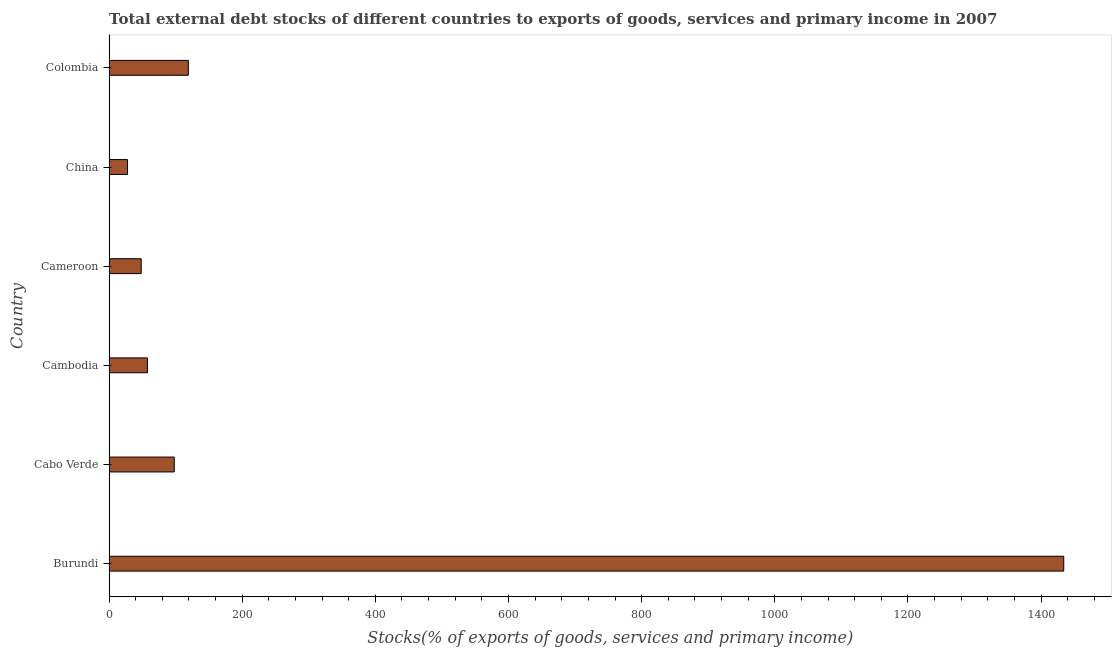Does the graph contain any zero values?
Provide a short and direct response. No. Does the graph contain grids?
Offer a terse response. No. What is the title of the graph?
Keep it short and to the point. Total external debt stocks of different countries to exports of goods, services and primary income in 2007. What is the label or title of the X-axis?
Offer a very short reply. Stocks(% of exports of goods, services and primary income). What is the external debt stocks in Cameroon?
Provide a succinct answer. 48.27. Across all countries, what is the maximum external debt stocks?
Your answer should be very brief. 1434.09. Across all countries, what is the minimum external debt stocks?
Offer a terse response. 27.76. In which country was the external debt stocks maximum?
Provide a short and direct response. Burundi. What is the sum of the external debt stocks?
Provide a succinct answer. 1784.75. What is the difference between the external debt stocks in Cabo Verde and Cambodia?
Your response must be concise. 40.35. What is the average external debt stocks per country?
Your answer should be compact. 297.46. What is the median external debt stocks?
Make the answer very short. 77.77. What is the ratio of the external debt stocks in Burundi to that in Cabo Verde?
Offer a very short reply. 14.64. Is the difference between the external debt stocks in Burundi and Cabo Verde greater than the difference between any two countries?
Offer a terse response. No. What is the difference between the highest and the second highest external debt stocks?
Your response must be concise. 1315.01. Is the sum of the external debt stocks in Cameroon and Colombia greater than the maximum external debt stocks across all countries?
Offer a terse response. No. What is the difference between the highest and the lowest external debt stocks?
Your answer should be very brief. 1406.33. In how many countries, is the external debt stocks greater than the average external debt stocks taken over all countries?
Your answer should be compact. 1. Are all the bars in the graph horizontal?
Your answer should be compact. Yes. How many countries are there in the graph?
Ensure brevity in your answer.  6. What is the Stocks(% of exports of goods, services and primary income) in Burundi?
Offer a very short reply. 1434.09. What is the Stocks(% of exports of goods, services and primary income) in Cabo Verde?
Offer a very short reply. 97.95. What is the Stocks(% of exports of goods, services and primary income) of Cambodia?
Your answer should be very brief. 57.59. What is the Stocks(% of exports of goods, services and primary income) of Cameroon?
Give a very brief answer. 48.27. What is the Stocks(% of exports of goods, services and primary income) in China?
Provide a succinct answer. 27.76. What is the Stocks(% of exports of goods, services and primary income) of Colombia?
Give a very brief answer. 119.08. What is the difference between the Stocks(% of exports of goods, services and primary income) in Burundi and Cabo Verde?
Your answer should be very brief. 1336.15. What is the difference between the Stocks(% of exports of goods, services and primary income) in Burundi and Cambodia?
Make the answer very short. 1376.5. What is the difference between the Stocks(% of exports of goods, services and primary income) in Burundi and Cameroon?
Your answer should be compact. 1385.82. What is the difference between the Stocks(% of exports of goods, services and primary income) in Burundi and China?
Keep it short and to the point. 1406.33. What is the difference between the Stocks(% of exports of goods, services and primary income) in Burundi and Colombia?
Your response must be concise. 1315.01. What is the difference between the Stocks(% of exports of goods, services and primary income) in Cabo Verde and Cambodia?
Give a very brief answer. 40.35. What is the difference between the Stocks(% of exports of goods, services and primary income) in Cabo Verde and Cameroon?
Your answer should be very brief. 49.67. What is the difference between the Stocks(% of exports of goods, services and primary income) in Cabo Verde and China?
Keep it short and to the point. 70.18. What is the difference between the Stocks(% of exports of goods, services and primary income) in Cabo Verde and Colombia?
Keep it short and to the point. -21.14. What is the difference between the Stocks(% of exports of goods, services and primary income) in Cambodia and Cameroon?
Keep it short and to the point. 9.32. What is the difference between the Stocks(% of exports of goods, services and primary income) in Cambodia and China?
Your answer should be very brief. 29.83. What is the difference between the Stocks(% of exports of goods, services and primary income) in Cambodia and Colombia?
Provide a succinct answer. -61.49. What is the difference between the Stocks(% of exports of goods, services and primary income) in Cameroon and China?
Your answer should be compact. 20.51. What is the difference between the Stocks(% of exports of goods, services and primary income) in Cameroon and Colombia?
Make the answer very short. -70.81. What is the difference between the Stocks(% of exports of goods, services and primary income) in China and Colombia?
Provide a succinct answer. -91.32. What is the ratio of the Stocks(% of exports of goods, services and primary income) in Burundi to that in Cabo Verde?
Make the answer very short. 14.64. What is the ratio of the Stocks(% of exports of goods, services and primary income) in Burundi to that in Cambodia?
Your answer should be compact. 24.9. What is the ratio of the Stocks(% of exports of goods, services and primary income) in Burundi to that in Cameroon?
Your response must be concise. 29.71. What is the ratio of the Stocks(% of exports of goods, services and primary income) in Burundi to that in China?
Provide a short and direct response. 51.65. What is the ratio of the Stocks(% of exports of goods, services and primary income) in Burundi to that in Colombia?
Your response must be concise. 12.04. What is the ratio of the Stocks(% of exports of goods, services and primary income) in Cabo Verde to that in Cambodia?
Provide a succinct answer. 1.7. What is the ratio of the Stocks(% of exports of goods, services and primary income) in Cabo Verde to that in Cameroon?
Provide a short and direct response. 2.03. What is the ratio of the Stocks(% of exports of goods, services and primary income) in Cabo Verde to that in China?
Ensure brevity in your answer.  3.53. What is the ratio of the Stocks(% of exports of goods, services and primary income) in Cabo Verde to that in Colombia?
Offer a terse response. 0.82. What is the ratio of the Stocks(% of exports of goods, services and primary income) in Cambodia to that in Cameroon?
Provide a short and direct response. 1.19. What is the ratio of the Stocks(% of exports of goods, services and primary income) in Cambodia to that in China?
Your response must be concise. 2.07. What is the ratio of the Stocks(% of exports of goods, services and primary income) in Cambodia to that in Colombia?
Your answer should be very brief. 0.48. What is the ratio of the Stocks(% of exports of goods, services and primary income) in Cameroon to that in China?
Provide a short and direct response. 1.74. What is the ratio of the Stocks(% of exports of goods, services and primary income) in Cameroon to that in Colombia?
Give a very brief answer. 0.41. What is the ratio of the Stocks(% of exports of goods, services and primary income) in China to that in Colombia?
Your answer should be compact. 0.23. 